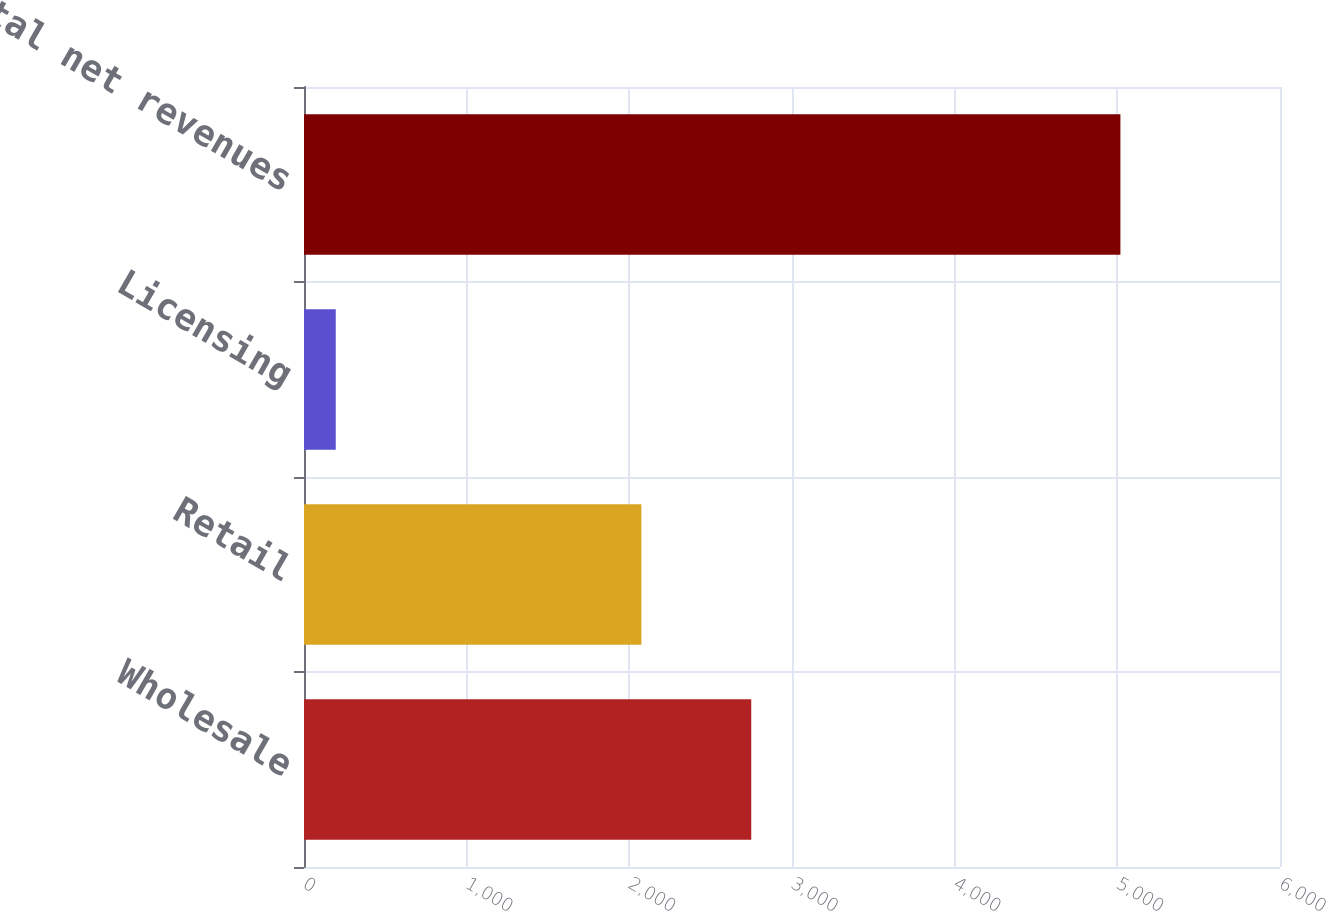Convert chart. <chart><loc_0><loc_0><loc_500><loc_500><bar_chart><fcel>Wholesale<fcel>Retail<fcel>Licensing<fcel>Total net revenues<nl><fcel>2749.5<fcel>2074.2<fcel>195.2<fcel>5018.9<nl></chart> 